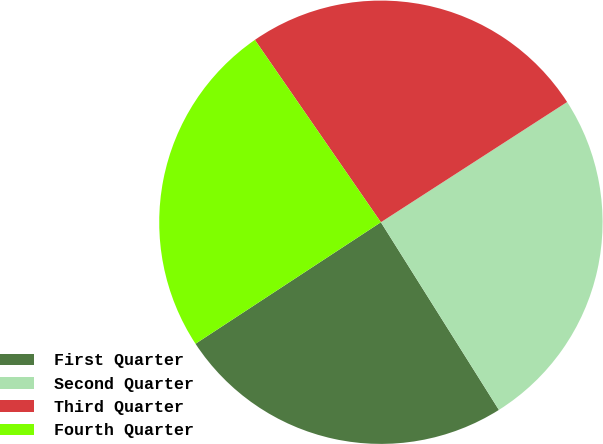Convert chart. <chart><loc_0><loc_0><loc_500><loc_500><pie_chart><fcel>First Quarter<fcel>Second Quarter<fcel>Third Quarter<fcel>Fourth Quarter<nl><fcel>24.7%<fcel>25.19%<fcel>25.5%<fcel>24.61%<nl></chart> 